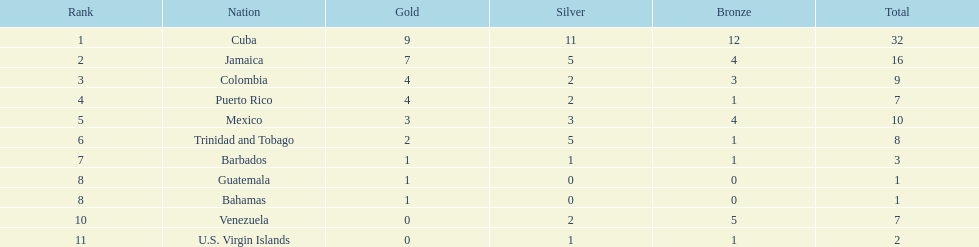The nation prior to mexico in the list Puerto Rico. 